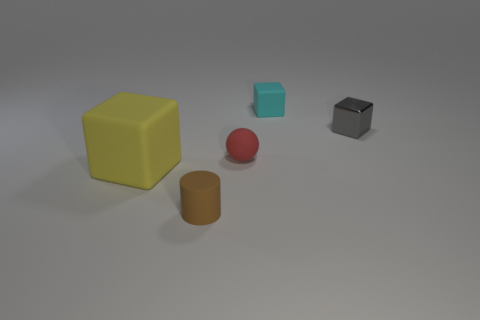Are there any other things that have the same material as the tiny gray cube?
Provide a short and direct response. No. There is a thing that is to the left of the small cylinder; how many cyan blocks are on the left side of it?
Your answer should be very brief. 0. How many things are blocks in front of the tiny cyan block or small matte cylinders?
Offer a terse response. 3. How many tiny cyan balls are made of the same material as the red thing?
Provide a succinct answer. 0. Are there an equal number of rubber cylinders behind the small brown rubber thing and big blue rubber cylinders?
Make the answer very short. Yes. How big is the cube on the left side of the matte cylinder?
Your answer should be compact. Large. What number of small things are either gray shiny cubes or red balls?
Provide a succinct answer. 2. The other rubber object that is the same shape as the yellow object is what color?
Your answer should be compact. Cyan. Do the yellow rubber object and the gray metallic thing have the same size?
Your answer should be compact. No. How many objects are either matte cylinders or matte blocks behind the gray cube?
Provide a succinct answer. 2. 